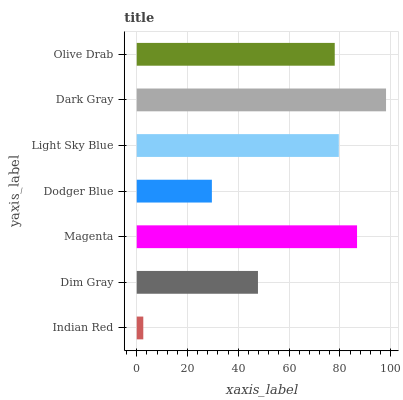Is Indian Red the minimum?
Answer yes or no. Yes. Is Dark Gray the maximum?
Answer yes or no. Yes. Is Dim Gray the minimum?
Answer yes or no. No. Is Dim Gray the maximum?
Answer yes or no. No. Is Dim Gray greater than Indian Red?
Answer yes or no. Yes. Is Indian Red less than Dim Gray?
Answer yes or no. Yes. Is Indian Red greater than Dim Gray?
Answer yes or no. No. Is Dim Gray less than Indian Red?
Answer yes or no. No. Is Olive Drab the high median?
Answer yes or no. Yes. Is Olive Drab the low median?
Answer yes or no. Yes. Is Indian Red the high median?
Answer yes or no. No. Is Magenta the low median?
Answer yes or no. No. 